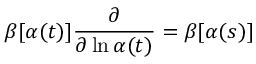Convert formula to latex. <formula><loc_0><loc_0><loc_500><loc_500>\beta [ \alpha ( t ) ] \frac { \partial } { \partial \ln \alpha ( t ) } = \beta [ \alpha ( s ) ]</formula> 